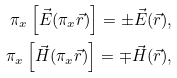<formula> <loc_0><loc_0><loc_500><loc_500>\pi _ { x } \left [ \vec { E } ( \pi _ { x } \vec { r } ) \right ] = \pm \vec { E } ( \vec { r } ) , \\ \pi _ { x } \left [ \vec { H } ( \pi _ { x } \vec { r } ) \right ] = \mp \vec { H } ( \vec { r } ) ,</formula> 